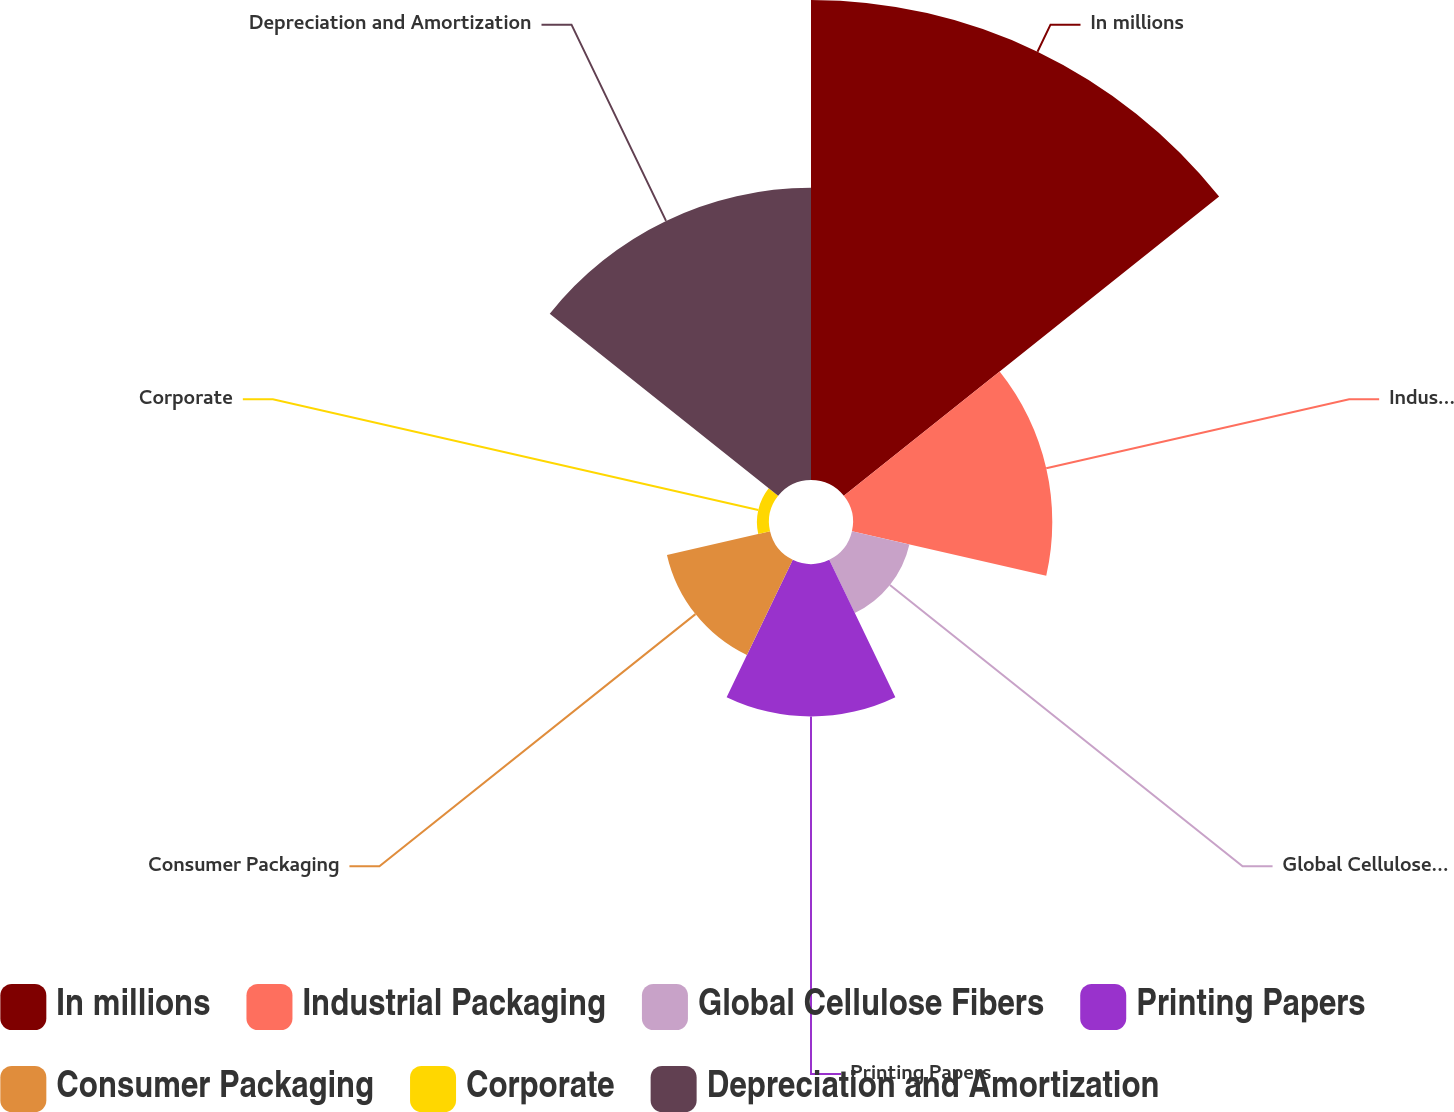Convert chart to OTSL. <chart><loc_0><loc_0><loc_500><loc_500><pie_chart><fcel>In millions<fcel>Industrial Packaging<fcel>Global Cellulose Fibers<fcel>Printing Papers<fcel>Consumer Packaging<fcel>Corporate<fcel>Depreciation and Amortization<nl><fcel>36.9%<fcel>15.32%<fcel>4.53%<fcel>11.72%<fcel>8.13%<fcel>0.93%<fcel>22.46%<nl></chart> 